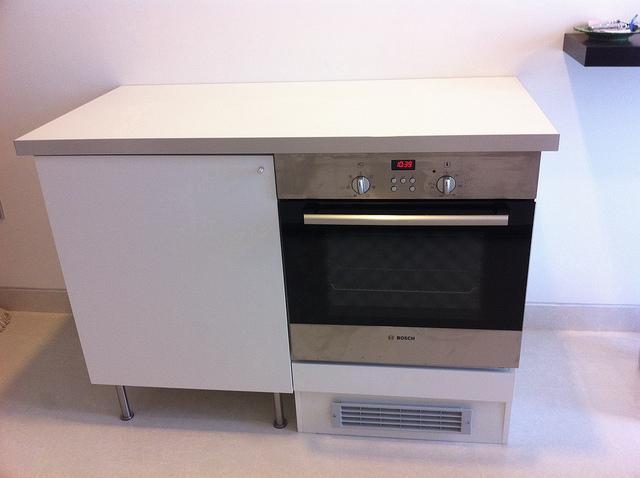How many people are visible?
Give a very brief answer. 0. 